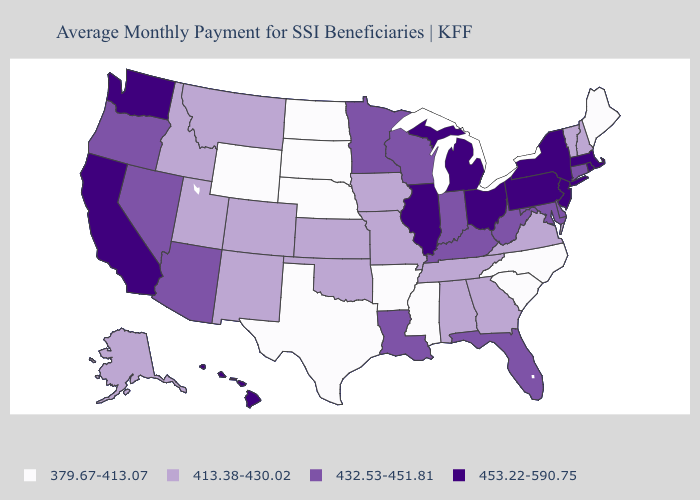What is the highest value in the USA?
Write a very short answer. 453.22-590.75. Name the states that have a value in the range 432.53-451.81?
Answer briefly. Arizona, Connecticut, Delaware, Florida, Indiana, Kentucky, Louisiana, Maryland, Minnesota, Nevada, Oregon, West Virginia, Wisconsin. What is the lowest value in states that border Nebraska?
Be succinct. 379.67-413.07. Does Wyoming have the lowest value in the West?
Be succinct. Yes. Does the first symbol in the legend represent the smallest category?
Concise answer only. Yes. What is the lowest value in the USA?
Concise answer only. 379.67-413.07. Is the legend a continuous bar?
Keep it brief. No. Which states have the highest value in the USA?
Concise answer only. California, Hawaii, Illinois, Massachusetts, Michigan, New Jersey, New York, Ohio, Pennsylvania, Rhode Island, Washington. Does Arkansas have a lower value than Kentucky?
Answer briefly. Yes. Does the first symbol in the legend represent the smallest category?
Concise answer only. Yes. Is the legend a continuous bar?
Write a very short answer. No. Does Kansas have the highest value in the USA?
Give a very brief answer. No. Name the states that have a value in the range 379.67-413.07?
Concise answer only. Arkansas, Maine, Mississippi, Nebraska, North Carolina, North Dakota, South Carolina, South Dakota, Texas, Wyoming. Which states have the highest value in the USA?
Concise answer only. California, Hawaii, Illinois, Massachusetts, Michigan, New Jersey, New York, Ohio, Pennsylvania, Rhode Island, Washington. How many symbols are there in the legend?
Write a very short answer. 4. 